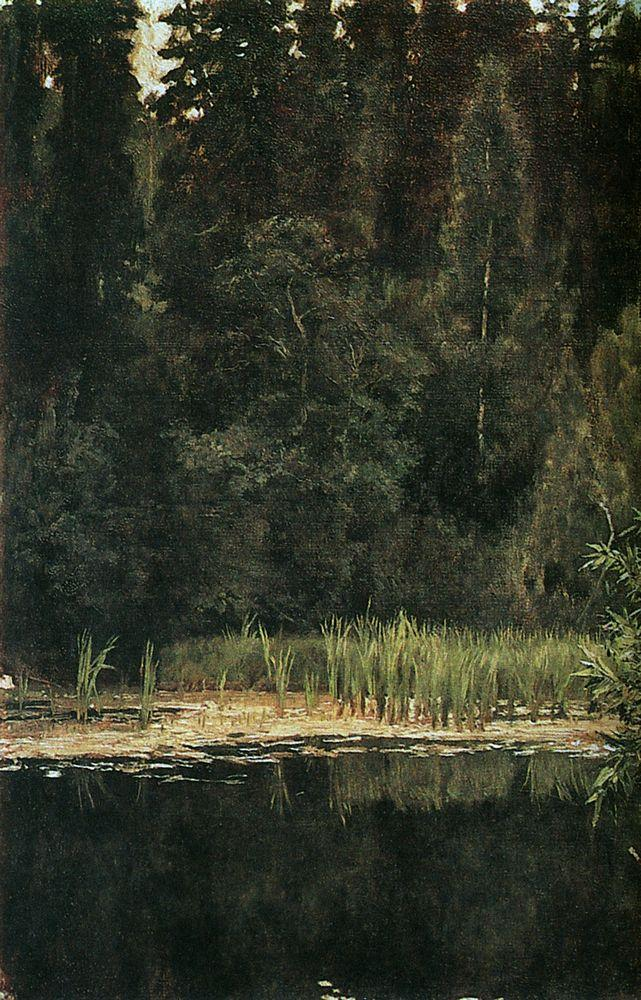Can you describe the main features of this image for me?
 The image is an oil painting that depicts a serene forest scene. The foreground is dominated by a tranquil pond, its surface so still that it mirrors the surrounding trees and the sky above. The landscape is rendered in a realistic style, with the artist's brushstrokes meticulously capturing the texture and depth of the foliage. The color palette is dominated by shades of green and brown, reflecting the natural hues of the forest. The art genre of this piece can be classified as landscape painting. The overall composition and the artist's attention to detail create a sense of tranquility and harmony with nature. 